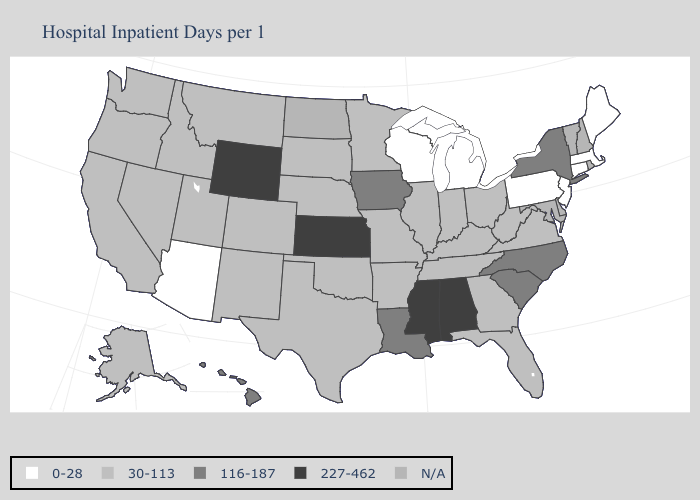Name the states that have a value in the range 30-113?
Answer briefly. Alaska, Arkansas, California, Colorado, Florida, Georgia, Idaho, Illinois, Indiana, Kentucky, Minnesota, Missouri, Montana, Nebraska, Nevada, New Mexico, Ohio, Oklahoma, Oregon, South Dakota, Tennessee, Texas, Utah, Virginia, Washington, West Virginia. Which states have the lowest value in the Northeast?
Concise answer only. Connecticut, Maine, Massachusetts, New Jersey, Pennsylvania. Does Wisconsin have the lowest value in the MidWest?
Write a very short answer. Yes. Which states have the highest value in the USA?
Write a very short answer. Alabama, Kansas, Mississippi, Wyoming. What is the value of Tennessee?
Give a very brief answer. 30-113. What is the highest value in the Northeast ?
Quick response, please. 116-187. Name the states that have a value in the range 116-187?
Keep it brief. Hawaii, Iowa, Louisiana, New York, North Carolina, South Carolina. What is the value of Delaware?
Keep it brief. N/A. What is the lowest value in states that border Idaho?
Short answer required. 30-113. What is the value of Kentucky?
Quick response, please. 30-113. Name the states that have a value in the range 0-28?
Quick response, please. Arizona, Connecticut, Maine, Massachusetts, Michigan, New Jersey, Pennsylvania, Wisconsin. What is the highest value in the South ?
Keep it brief. 227-462. Name the states that have a value in the range 0-28?
Keep it brief. Arizona, Connecticut, Maine, Massachusetts, Michigan, New Jersey, Pennsylvania, Wisconsin. Which states have the highest value in the USA?
Short answer required. Alabama, Kansas, Mississippi, Wyoming. What is the value of Louisiana?
Be succinct. 116-187. 